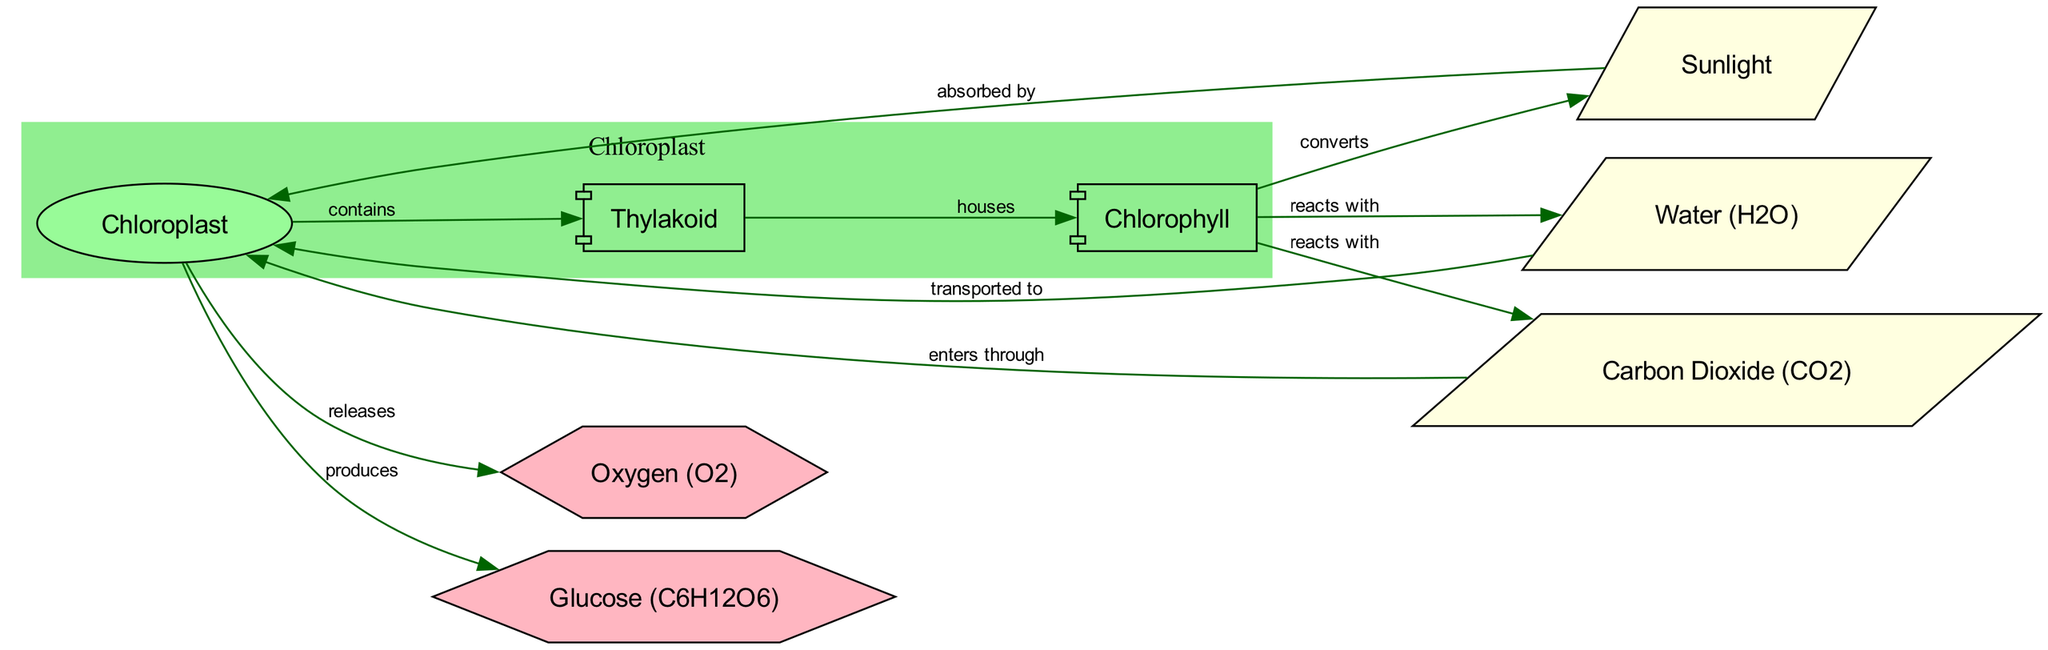What is the role of sunlight in the photosynthesis process? According to the diagram, sunlight is "absorbed by" the chloroplast, indicating that it plays a crucial role in initiating the photosynthesis process.
Answer: absorbed by What does water transport to in the diagram? The diagram shows that water (H2O) is "transported to" the chloroplast, where it is used in the photosynthesis process.
Answer: chloroplast How many nodes are present in the diagram? By counting all unique entities in the diagram, we find that there are a total of eight nodes that are represented as different materials or structures involved in the photosynthesis process.
Answer: eight Which component contains chlorophyll? The diagram indicates that the thylakoid "houses" chlorophyll, meaning that chlorophyll is found within the thylakoid structure, which is part of the chloroplast.
Answer: thylakoid What gas is released as a by-product of photosynthesis? The diagram explicitly states that oxygen (O2) is "released" from the chloroplast, confirming it as a by-product of the photosynthesis process.
Answer: oxygen (O2) What do chlorophyll and sunlight do together in the diagram? The relationship depicted in the diagram shows that chlorophyll "converts" sunlight, meaning that chlorophyll harnesses sunlight energy to facilitate the process of photosynthesis.
Answer: converts Which substances react with chlorophyll during photosynthesis? The diagram shows that chlorophyll "reacts with" water (H2O) and carbon dioxide (CO2) in the chloroplast, which are essential materials for the photosynthesis process.
Answer: water (H2O), carbon dioxide (CO2) What is produced in the chloroplast during photosynthesis? The diagram indicates that the chloroplast "produces" glucose (C6H12O6), which is the end product of the photosynthesis process.
Answer: glucose (C6H12O6) 